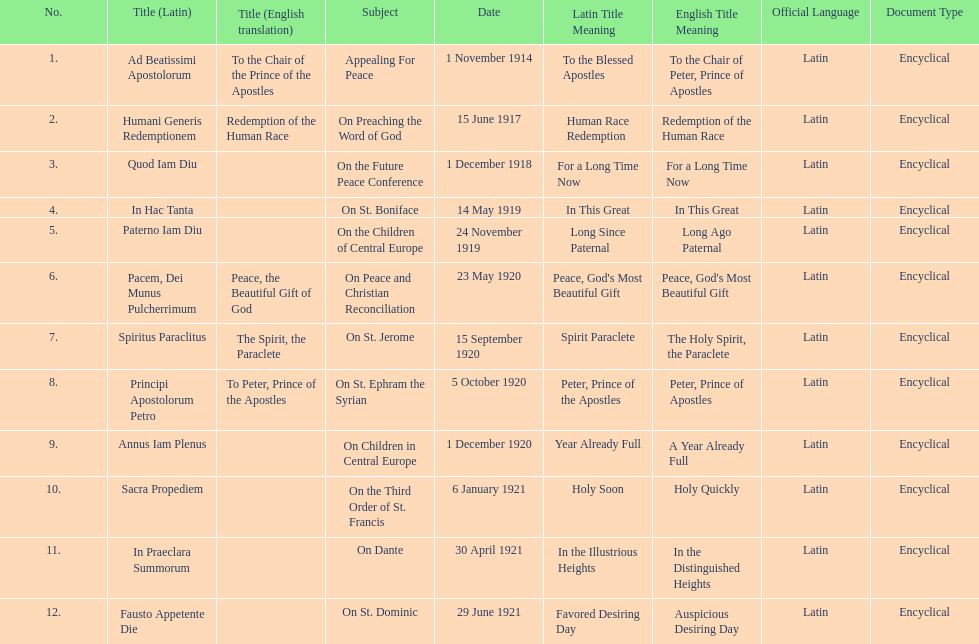How many titles did not list an english translation? 7. 